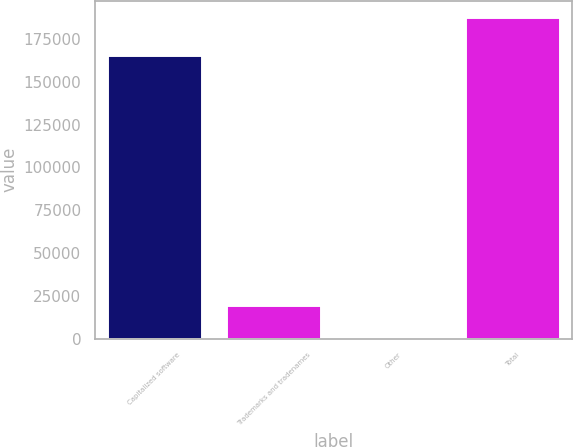Convert chart. <chart><loc_0><loc_0><loc_500><loc_500><bar_chart><fcel>Capitalized software<fcel>Trademarks and tradenames<fcel>Other<fcel>Total<nl><fcel>165565<fcel>19420.2<fcel>690<fcel>187992<nl></chart> 